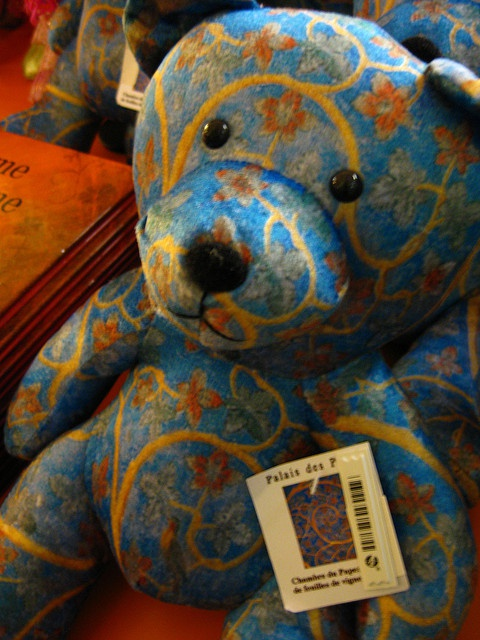Describe the objects in this image and their specific colors. I can see a teddy bear in maroon, black, gray, and olive tones in this image. 